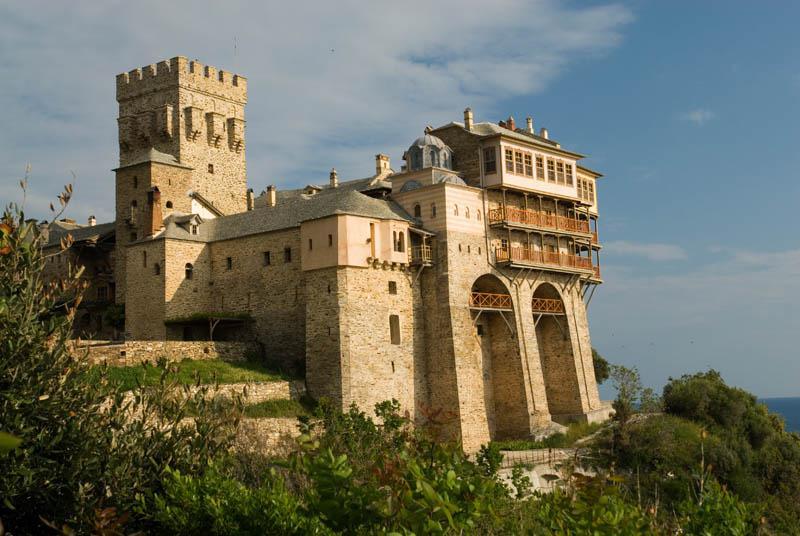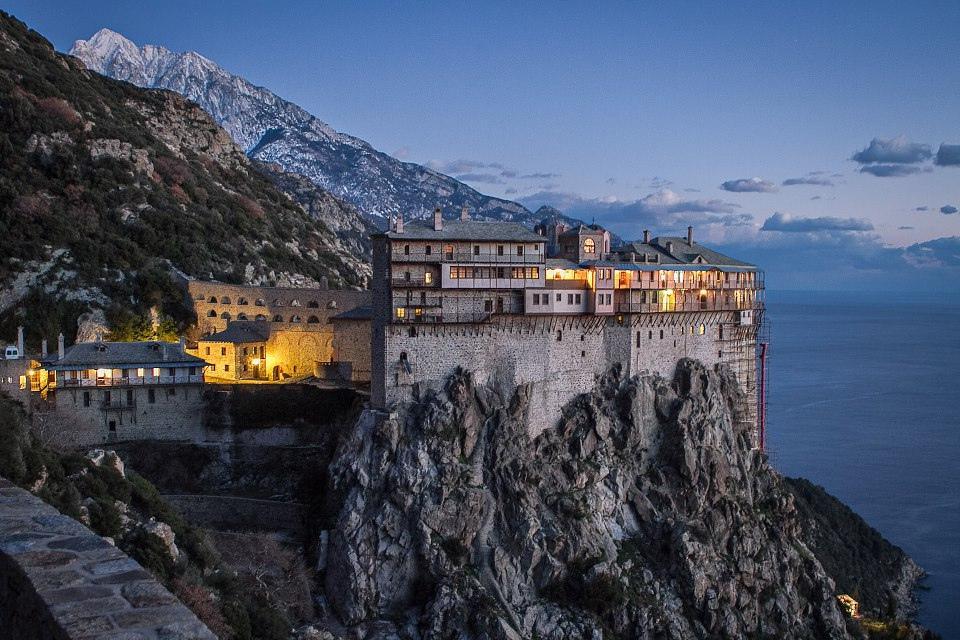The first image is the image on the left, the second image is the image on the right. Examine the images to the left and right. Is the description "The ocean is visible behind the buildings and cliffside in the left image, but it is not visible in the right image." accurate? Answer yes or no. No. 